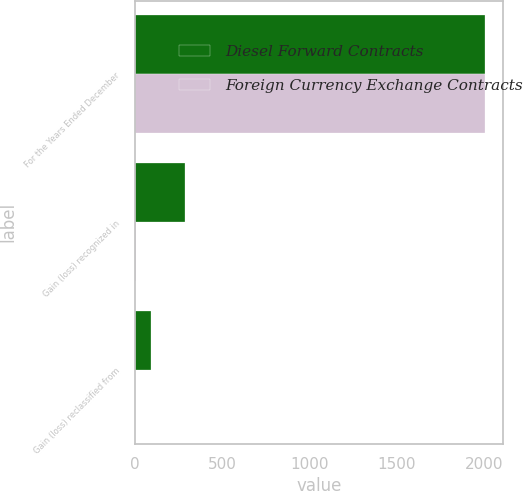Convert chart. <chart><loc_0><loc_0><loc_500><loc_500><stacked_bar_chart><ecel><fcel>For the Years Ended December<fcel>Gain (loss) recognized in<fcel>Gain (loss) reclassified from<nl><fcel>Diesel Forward Contracts<fcel>2010<fcel>287<fcel>92<nl><fcel>Foreign Currency Exchange Contracts<fcel>2010<fcel>6<fcel>4<nl></chart> 